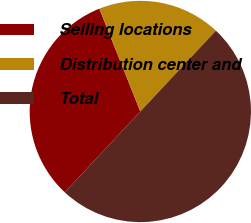<chart> <loc_0><loc_0><loc_500><loc_500><pie_chart><fcel>Selling locations<fcel>Distribution center and<fcel>Total<nl><fcel>32.0%<fcel>18.0%<fcel>50.0%<nl></chart> 